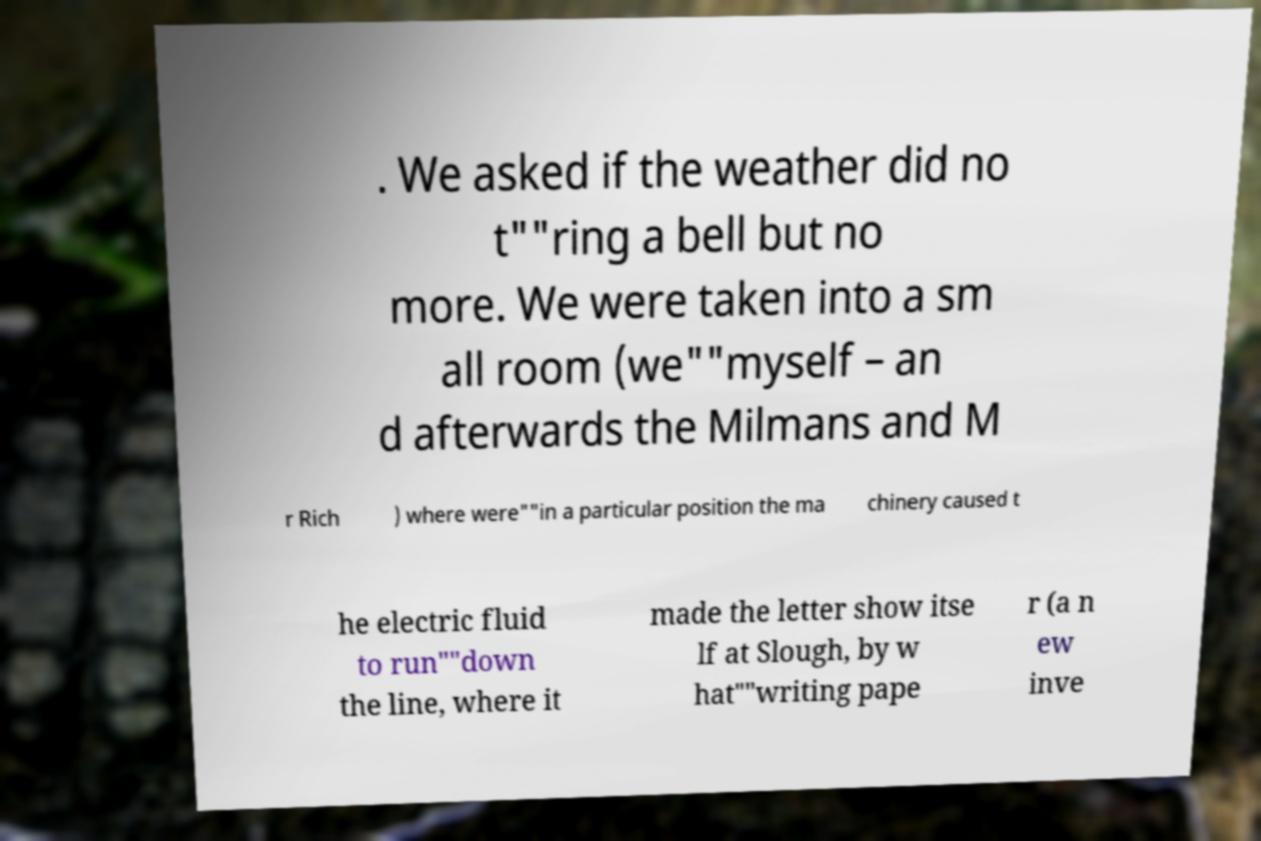Could you assist in decoding the text presented in this image and type it out clearly? . We asked if the weather did no t""ring a bell but no more. We were taken into a sm all room (we""myself – an d afterwards the Milmans and M r Rich ) where were""in a particular position the ma chinery caused t he electric fluid to run""down the line, where it made the letter show itse lf at Slough, by w hat""writing pape r (a n ew inve 